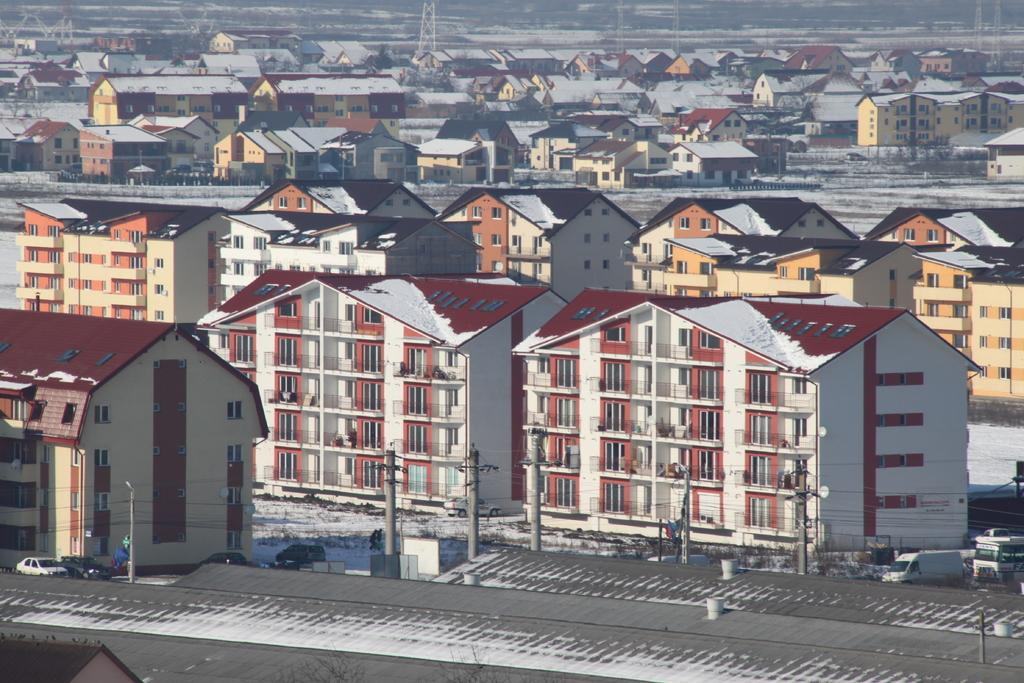What type of structures are visible in the image? There are houses in the image. Can you describe the vehicles in the image? There are two cars parked in front of a building in the image. What type of haircut does the brother have in the image? There is no brother or haircut mentioned in the image; it only features houses and parked cars. 